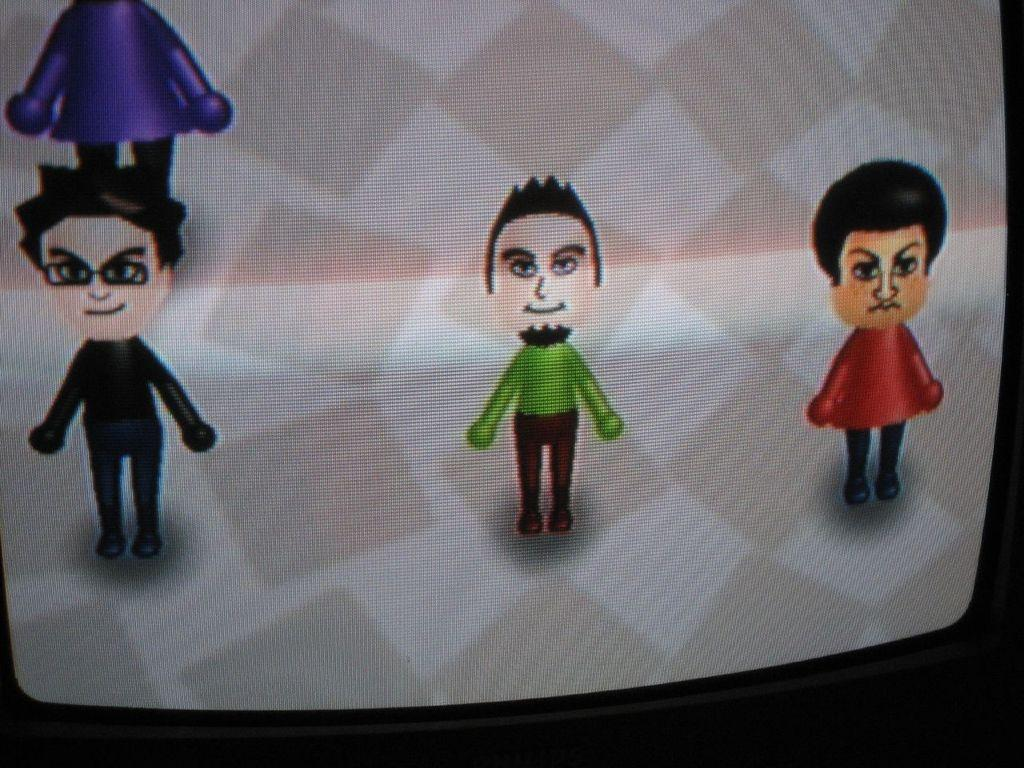How many cartoon characters are in the image? There are three cartoon characters in the image. Where are the cartoon characters located? The cartoon characters are on the screen. What type of office furniture can be seen in the image? There is no office furniture present in the image; it features three cartoon characters on the screen. What texture is visible on the sticks in the image? There are no sticks present in the image, only cartoon characters on the screen. 